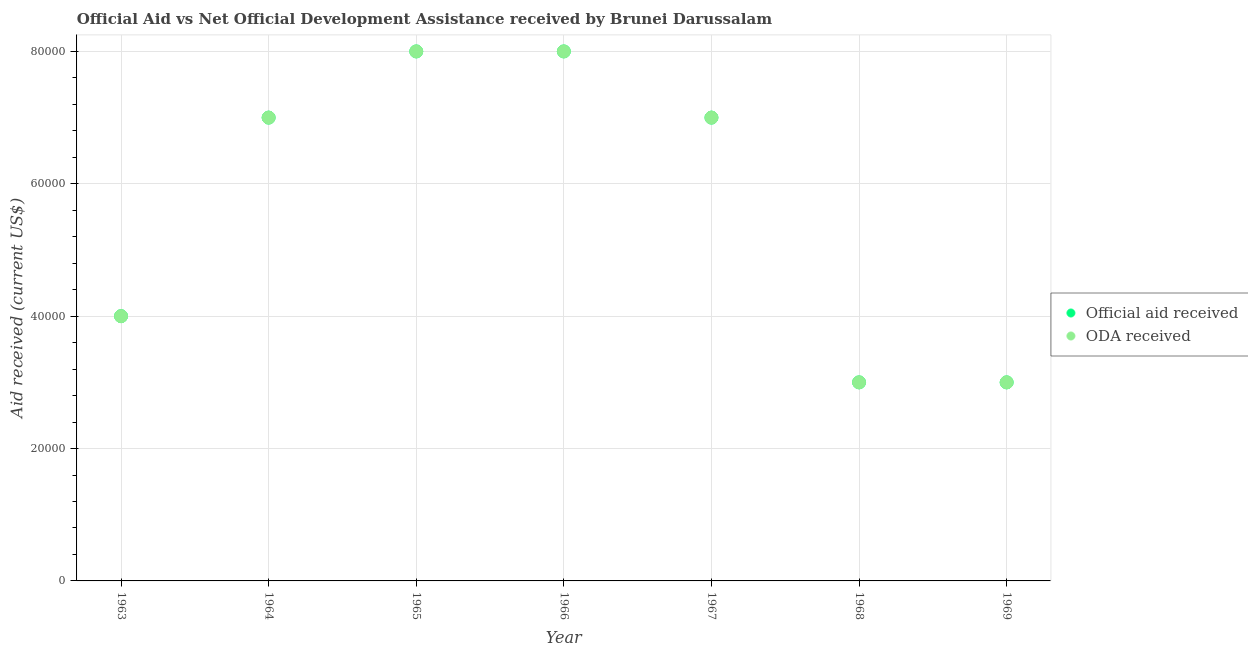How many different coloured dotlines are there?
Ensure brevity in your answer.  2. What is the official aid received in 1965?
Your answer should be compact. 8.00e+04. Across all years, what is the maximum oda received?
Make the answer very short. 8.00e+04. Across all years, what is the minimum oda received?
Ensure brevity in your answer.  3.00e+04. In which year was the oda received maximum?
Provide a short and direct response. 1965. In which year was the oda received minimum?
Offer a terse response. 1968. What is the total oda received in the graph?
Ensure brevity in your answer.  4.00e+05. What is the difference between the oda received in 1963 and that in 1964?
Give a very brief answer. -3.00e+04. What is the difference between the oda received in 1963 and the official aid received in 1965?
Make the answer very short. -4.00e+04. What is the average oda received per year?
Your answer should be compact. 5.71e+04. What is the ratio of the oda received in 1965 to that in 1967?
Keep it short and to the point. 1.14. What is the difference between the highest and the second highest oda received?
Give a very brief answer. 0. What is the difference between the highest and the lowest oda received?
Offer a very short reply. 5.00e+04. Does the official aid received monotonically increase over the years?
Offer a very short reply. No. Is the official aid received strictly greater than the oda received over the years?
Your answer should be very brief. No. Is the official aid received strictly less than the oda received over the years?
Your answer should be very brief. No. How many dotlines are there?
Give a very brief answer. 2. What is the difference between two consecutive major ticks on the Y-axis?
Ensure brevity in your answer.  2.00e+04. Does the graph contain grids?
Your response must be concise. Yes. What is the title of the graph?
Your answer should be compact. Official Aid vs Net Official Development Assistance received by Brunei Darussalam . Does "Depositors" appear as one of the legend labels in the graph?
Keep it short and to the point. No. What is the label or title of the X-axis?
Provide a succinct answer. Year. What is the label or title of the Y-axis?
Offer a terse response. Aid received (current US$). What is the Aid received (current US$) in Official aid received in 1963?
Make the answer very short. 4.00e+04. What is the Aid received (current US$) of ODA received in 1963?
Offer a very short reply. 4.00e+04. What is the Aid received (current US$) in ODA received in 1965?
Ensure brevity in your answer.  8.00e+04. What is the Aid received (current US$) in Official aid received in 1966?
Provide a succinct answer. 8.00e+04. What is the Aid received (current US$) in ODA received in 1966?
Ensure brevity in your answer.  8.00e+04. What is the Aid received (current US$) of Official aid received in 1967?
Give a very brief answer. 7.00e+04. What is the Aid received (current US$) of ODA received in 1967?
Ensure brevity in your answer.  7.00e+04. What is the Aid received (current US$) in Official aid received in 1968?
Make the answer very short. 3.00e+04. What is the Aid received (current US$) in Official aid received in 1969?
Keep it short and to the point. 3.00e+04. What is the Aid received (current US$) in ODA received in 1969?
Keep it short and to the point. 3.00e+04. What is the difference between the Aid received (current US$) in Official aid received in 1963 and that in 1964?
Provide a short and direct response. -3.00e+04. What is the difference between the Aid received (current US$) in ODA received in 1963 and that in 1964?
Provide a succinct answer. -3.00e+04. What is the difference between the Aid received (current US$) of Official aid received in 1963 and that in 1965?
Your answer should be very brief. -4.00e+04. What is the difference between the Aid received (current US$) of ODA received in 1963 and that in 1965?
Give a very brief answer. -4.00e+04. What is the difference between the Aid received (current US$) in Official aid received in 1963 and that in 1966?
Keep it short and to the point. -4.00e+04. What is the difference between the Aid received (current US$) in ODA received in 1963 and that in 1966?
Your response must be concise. -4.00e+04. What is the difference between the Aid received (current US$) of Official aid received in 1963 and that in 1967?
Provide a succinct answer. -3.00e+04. What is the difference between the Aid received (current US$) of ODA received in 1963 and that in 1967?
Your response must be concise. -3.00e+04. What is the difference between the Aid received (current US$) of ODA received in 1963 and that in 1968?
Ensure brevity in your answer.  10000. What is the difference between the Aid received (current US$) in Official aid received in 1963 and that in 1969?
Offer a very short reply. 10000. What is the difference between the Aid received (current US$) of Official aid received in 1964 and that in 1965?
Your answer should be compact. -10000. What is the difference between the Aid received (current US$) of Official aid received in 1964 and that in 1966?
Ensure brevity in your answer.  -10000. What is the difference between the Aid received (current US$) of Official aid received in 1964 and that in 1967?
Provide a short and direct response. 0. What is the difference between the Aid received (current US$) in Official aid received in 1964 and that in 1968?
Ensure brevity in your answer.  4.00e+04. What is the difference between the Aid received (current US$) of Official aid received in 1964 and that in 1969?
Your answer should be very brief. 4.00e+04. What is the difference between the Aid received (current US$) of ODA received in 1964 and that in 1969?
Keep it short and to the point. 4.00e+04. What is the difference between the Aid received (current US$) in Official aid received in 1965 and that in 1966?
Make the answer very short. 0. What is the difference between the Aid received (current US$) of ODA received in 1965 and that in 1967?
Offer a terse response. 10000. What is the difference between the Aid received (current US$) in ODA received in 1965 and that in 1968?
Provide a short and direct response. 5.00e+04. What is the difference between the Aid received (current US$) in ODA received in 1966 and that in 1968?
Provide a short and direct response. 5.00e+04. What is the difference between the Aid received (current US$) of Official aid received in 1966 and that in 1969?
Give a very brief answer. 5.00e+04. What is the difference between the Aid received (current US$) in ODA received in 1966 and that in 1969?
Make the answer very short. 5.00e+04. What is the difference between the Aid received (current US$) of Official aid received in 1967 and that in 1968?
Make the answer very short. 4.00e+04. What is the difference between the Aid received (current US$) in ODA received in 1967 and that in 1968?
Ensure brevity in your answer.  4.00e+04. What is the difference between the Aid received (current US$) of ODA received in 1968 and that in 1969?
Your answer should be very brief. 0. What is the difference between the Aid received (current US$) of Official aid received in 1963 and the Aid received (current US$) of ODA received in 1965?
Your response must be concise. -4.00e+04. What is the difference between the Aid received (current US$) of Official aid received in 1963 and the Aid received (current US$) of ODA received in 1966?
Keep it short and to the point. -4.00e+04. What is the difference between the Aid received (current US$) of Official aid received in 1963 and the Aid received (current US$) of ODA received in 1967?
Keep it short and to the point. -3.00e+04. What is the difference between the Aid received (current US$) in Official aid received in 1963 and the Aid received (current US$) in ODA received in 1968?
Offer a very short reply. 10000. What is the difference between the Aid received (current US$) of Official aid received in 1964 and the Aid received (current US$) of ODA received in 1966?
Your answer should be very brief. -10000. What is the difference between the Aid received (current US$) in Official aid received in 1964 and the Aid received (current US$) in ODA received in 1968?
Offer a terse response. 4.00e+04. What is the difference between the Aid received (current US$) of Official aid received in 1964 and the Aid received (current US$) of ODA received in 1969?
Provide a succinct answer. 4.00e+04. What is the difference between the Aid received (current US$) of Official aid received in 1965 and the Aid received (current US$) of ODA received in 1966?
Your answer should be compact. 0. What is the difference between the Aid received (current US$) in Official aid received in 1965 and the Aid received (current US$) in ODA received in 1967?
Offer a terse response. 10000. What is the difference between the Aid received (current US$) of Official aid received in 1965 and the Aid received (current US$) of ODA received in 1969?
Provide a succinct answer. 5.00e+04. What is the difference between the Aid received (current US$) of Official aid received in 1966 and the Aid received (current US$) of ODA received in 1967?
Make the answer very short. 10000. What is the difference between the Aid received (current US$) of Official aid received in 1968 and the Aid received (current US$) of ODA received in 1969?
Make the answer very short. 0. What is the average Aid received (current US$) of Official aid received per year?
Offer a very short reply. 5.71e+04. What is the average Aid received (current US$) of ODA received per year?
Ensure brevity in your answer.  5.71e+04. In the year 1963, what is the difference between the Aid received (current US$) of Official aid received and Aid received (current US$) of ODA received?
Make the answer very short. 0. In the year 1968, what is the difference between the Aid received (current US$) of Official aid received and Aid received (current US$) of ODA received?
Your answer should be compact. 0. What is the ratio of the Aid received (current US$) in Official aid received in 1963 to that in 1964?
Provide a short and direct response. 0.57. What is the ratio of the Aid received (current US$) in Official aid received in 1963 to that in 1965?
Keep it short and to the point. 0.5. What is the ratio of the Aid received (current US$) in ODA received in 1963 to that in 1965?
Offer a terse response. 0.5. What is the ratio of the Aid received (current US$) of ODA received in 1963 to that in 1966?
Make the answer very short. 0.5. What is the ratio of the Aid received (current US$) in Official aid received in 1963 to that in 1969?
Your answer should be very brief. 1.33. What is the ratio of the Aid received (current US$) of ODA received in 1963 to that in 1969?
Provide a succinct answer. 1.33. What is the ratio of the Aid received (current US$) of ODA received in 1964 to that in 1965?
Give a very brief answer. 0.88. What is the ratio of the Aid received (current US$) of ODA received in 1964 to that in 1966?
Make the answer very short. 0.88. What is the ratio of the Aid received (current US$) in Official aid received in 1964 to that in 1967?
Provide a succinct answer. 1. What is the ratio of the Aid received (current US$) of Official aid received in 1964 to that in 1968?
Offer a terse response. 2.33. What is the ratio of the Aid received (current US$) in ODA received in 1964 to that in 1968?
Keep it short and to the point. 2.33. What is the ratio of the Aid received (current US$) of Official aid received in 1964 to that in 1969?
Provide a succinct answer. 2.33. What is the ratio of the Aid received (current US$) of ODA received in 1964 to that in 1969?
Your answer should be very brief. 2.33. What is the ratio of the Aid received (current US$) of ODA received in 1965 to that in 1966?
Keep it short and to the point. 1. What is the ratio of the Aid received (current US$) of ODA received in 1965 to that in 1967?
Ensure brevity in your answer.  1.14. What is the ratio of the Aid received (current US$) in Official aid received in 1965 to that in 1968?
Make the answer very short. 2.67. What is the ratio of the Aid received (current US$) in ODA received in 1965 to that in 1968?
Ensure brevity in your answer.  2.67. What is the ratio of the Aid received (current US$) in Official aid received in 1965 to that in 1969?
Provide a succinct answer. 2.67. What is the ratio of the Aid received (current US$) in ODA received in 1965 to that in 1969?
Ensure brevity in your answer.  2.67. What is the ratio of the Aid received (current US$) of Official aid received in 1966 to that in 1968?
Provide a short and direct response. 2.67. What is the ratio of the Aid received (current US$) of ODA received in 1966 to that in 1968?
Offer a very short reply. 2.67. What is the ratio of the Aid received (current US$) of Official aid received in 1966 to that in 1969?
Your answer should be compact. 2.67. What is the ratio of the Aid received (current US$) in ODA received in 1966 to that in 1969?
Offer a very short reply. 2.67. What is the ratio of the Aid received (current US$) in Official aid received in 1967 to that in 1968?
Your answer should be very brief. 2.33. What is the ratio of the Aid received (current US$) of ODA received in 1967 to that in 1968?
Your response must be concise. 2.33. What is the ratio of the Aid received (current US$) of Official aid received in 1967 to that in 1969?
Your response must be concise. 2.33. What is the ratio of the Aid received (current US$) in ODA received in 1967 to that in 1969?
Your answer should be very brief. 2.33. What is the ratio of the Aid received (current US$) in ODA received in 1968 to that in 1969?
Your answer should be compact. 1. What is the difference between the highest and the second highest Aid received (current US$) of Official aid received?
Offer a terse response. 0. What is the difference between the highest and the second highest Aid received (current US$) in ODA received?
Give a very brief answer. 0. What is the difference between the highest and the lowest Aid received (current US$) in Official aid received?
Make the answer very short. 5.00e+04. 